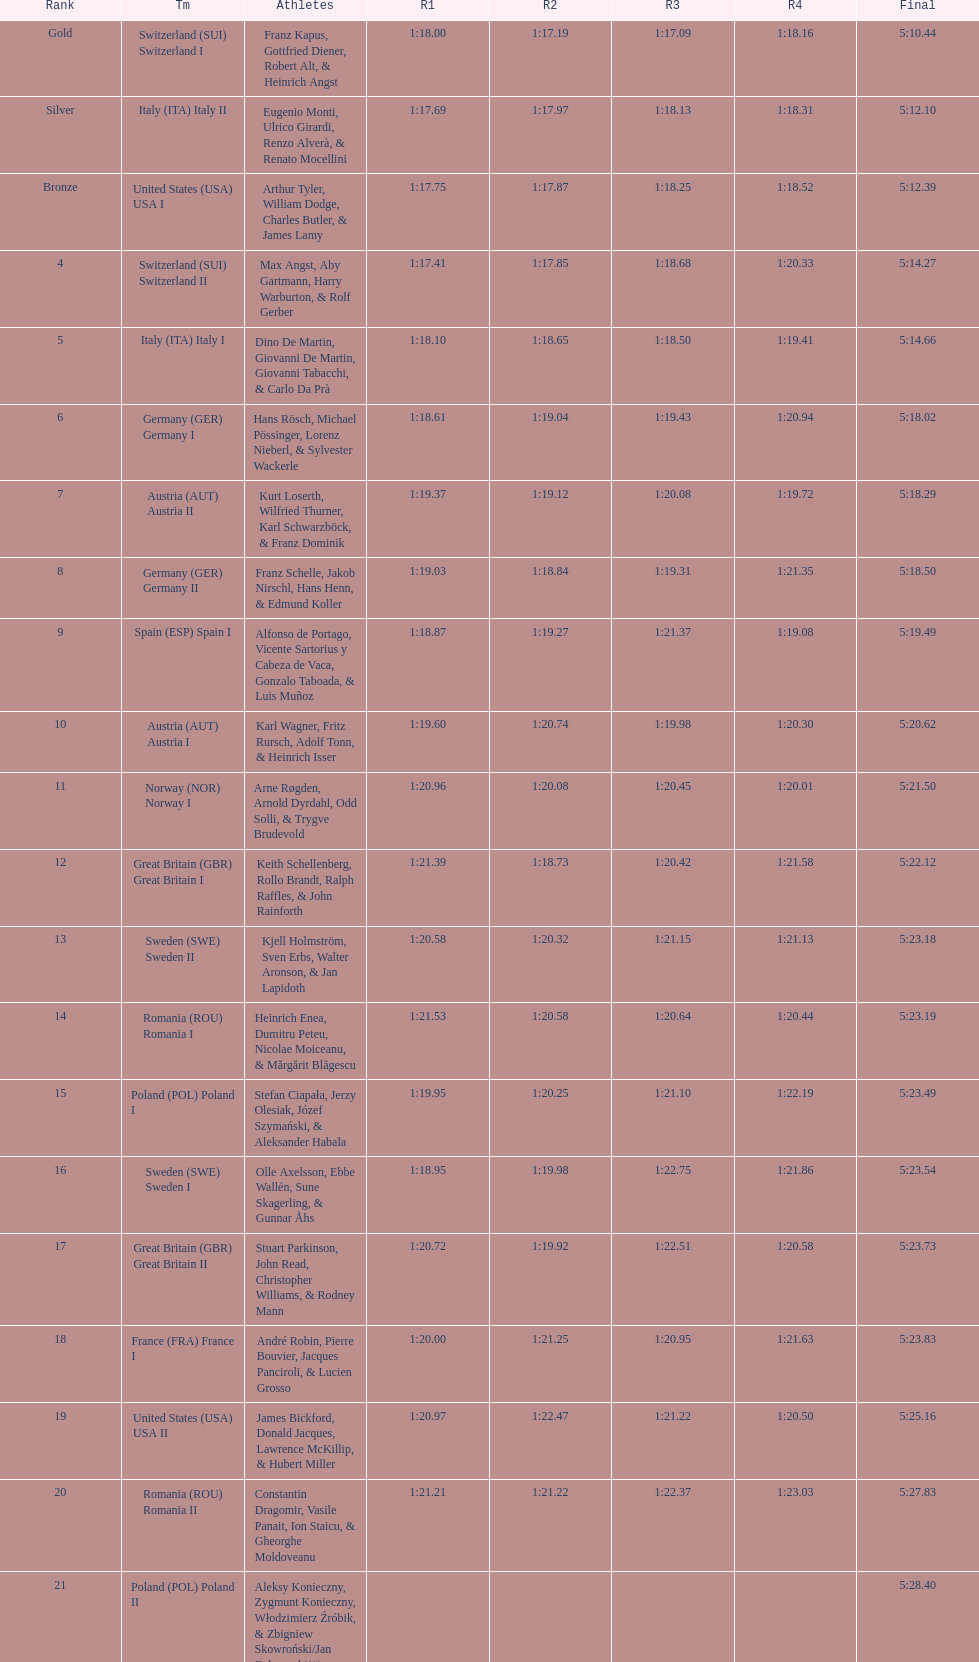Name a country that had 4 consecutive runs under 1:19. Switzerland. Give me the full table as a dictionary. {'header': ['Rank', 'Tm', 'Athletes', 'R1', 'R2', 'R3', 'R4', 'Final'], 'rows': [['Gold', 'Switzerland\xa0(SUI) Switzerland I', 'Franz Kapus, Gottfried Diener, Robert Alt, & Heinrich Angst', '1:18.00', '1:17.19', '1:17.09', '1:18.16', '5:10.44'], ['Silver', 'Italy\xa0(ITA) Italy II', 'Eugenio Monti, Ulrico Girardi, Renzo Alverà, & Renato Mocellini', '1:17.69', '1:17.97', '1:18.13', '1:18.31', '5:12.10'], ['Bronze', 'United States\xa0(USA) USA I', 'Arthur Tyler, William Dodge, Charles Butler, & James Lamy', '1:17.75', '1:17.87', '1:18.25', '1:18.52', '5:12.39'], ['4', 'Switzerland\xa0(SUI) Switzerland II', 'Max Angst, Aby Gartmann, Harry Warburton, & Rolf Gerber', '1:17.41', '1:17.85', '1:18.68', '1:20.33', '5:14.27'], ['5', 'Italy\xa0(ITA) Italy I', 'Dino De Martin, Giovanni De Martin, Giovanni Tabacchi, & Carlo Da Prà', '1:18.10', '1:18.65', '1:18.50', '1:19.41', '5:14.66'], ['6', 'Germany\xa0(GER) Germany I', 'Hans Rösch, Michael Pössinger, Lorenz Nieberl, & Sylvester Wackerle', '1:18.61', '1:19.04', '1:19.43', '1:20.94', '5:18.02'], ['7', 'Austria\xa0(AUT) Austria II', 'Kurt Loserth, Wilfried Thurner, Karl Schwarzböck, & Franz Dominik', '1:19.37', '1:19.12', '1:20.08', '1:19.72', '5:18.29'], ['8', 'Germany\xa0(GER) Germany II', 'Franz Schelle, Jakob Nirschl, Hans Henn, & Edmund Koller', '1:19.03', '1:18.84', '1:19.31', '1:21.35', '5:18.50'], ['9', 'Spain\xa0(ESP) Spain I', 'Alfonso de Portago, Vicente Sartorius y Cabeza de Vaca, Gonzalo Taboada, & Luis Muñoz', '1:18.87', '1:19.27', '1:21.37', '1:19.08', '5:19.49'], ['10', 'Austria\xa0(AUT) Austria I', 'Karl Wagner, Fritz Rursch, Adolf Tonn, & Heinrich Isser', '1:19.60', '1:20.74', '1:19.98', '1:20.30', '5:20.62'], ['11', 'Norway\xa0(NOR) Norway I', 'Arne Røgden, Arnold Dyrdahl, Odd Solli, & Trygve Brudevold', '1:20.96', '1:20.08', '1:20.45', '1:20.01', '5:21.50'], ['12', 'Great Britain\xa0(GBR) Great Britain I', 'Keith Schellenberg, Rollo Brandt, Ralph Raffles, & John Rainforth', '1:21.39', '1:18.73', '1:20.42', '1:21.58', '5:22.12'], ['13', 'Sweden\xa0(SWE) Sweden II', 'Kjell Holmström, Sven Erbs, Walter Aronson, & Jan Lapidoth', '1:20.58', '1:20.32', '1:21.15', '1:21.13', '5:23.18'], ['14', 'Romania\xa0(ROU) Romania I', 'Heinrich Enea, Dumitru Peteu, Nicolae Moiceanu, & Mărgărit Blăgescu', '1:21.53', '1:20.58', '1:20.64', '1:20.44', '5:23.19'], ['15', 'Poland\xa0(POL) Poland I', 'Stefan Ciapała, Jerzy Olesiak, Józef Szymański, & Aleksander Habala', '1:19.95', '1:20.25', '1:21.10', '1:22.19', '5:23.49'], ['16', 'Sweden\xa0(SWE) Sweden I', 'Olle Axelsson, Ebbe Wallén, Sune Skagerling, & Gunnar Åhs', '1:18.95', '1:19.98', '1:22.75', '1:21.86', '5:23.54'], ['17', 'Great Britain\xa0(GBR) Great Britain II', 'Stuart Parkinson, John Read, Christopher Williams, & Rodney Mann', '1:20.72', '1:19.92', '1:22.51', '1:20.58', '5:23.73'], ['18', 'France\xa0(FRA) France I', 'André Robin, Pierre Bouvier, Jacques Panciroli, & Lucien Grosso', '1:20.00', '1:21.25', '1:20.95', '1:21.63', '5:23.83'], ['19', 'United States\xa0(USA) USA II', 'James Bickford, Donald Jacques, Lawrence McKillip, & Hubert Miller', '1:20.97', '1:22.47', '1:21.22', '1:20.50', '5:25.16'], ['20', 'Romania\xa0(ROU) Romania II', 'Constantin Dragomir, Vasile Panait, Ion Staicu, & Gheorghe Moldoveanu', '1:21.21', '1:21.22', '1:22.37', '1:23.03', '5:27.83'], ['21', 'Poland\xa0(POL) Poland II', 'Aleksy Konieczny, Zygmunt Konieczny, Włodzimierz Źróbik, & Zbigniew Skowroński/Jan Dąbrowski(*)', '', '', '', '', '5:28.40']]} 